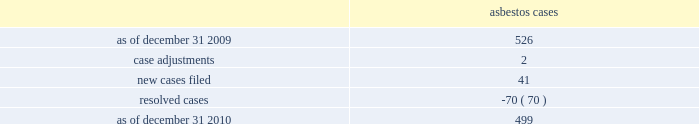Asbestos claims the company and several of its us subsidiaries are defendants in asbestos cases .
During the year ended december 31 , 2010 , asbestos case activity is as follows: .
Because many of these cases involve numerous plaintiffs , the company is subject to claims significantly in excess of the number of actual cases .
The company has reserves for defense costs related to claims arising from these matters .
Award proceedings in relation to domination agreement and squeeze-out on october 1 , 2004 , celanese gmbh and the company 2019s subsidiary , bcp holdings gmbh ( 201cbcp holdings 201d ) , a german limited liability company , entered into a domination agreement pursuant to which the bcp holdings became obligated to offer to acquire all outstanding celanese gmbh shares from the minority shareholders of celanese gmbh in return for payment of fair cash compensation ( the 201cpurchaser offer 201d ) .
The amount of this fair cash compensation was determined to be a41.92 per share in accordance with applicable german law .
All minority shareholders who elected not to sell their shares to the bcp holdings under the purchaser offer were entitled to remain shareholders of celanese gmbh and to receive from the bcp holdings a gross guaranteed annual payment of a3.27 per celanese gmbh share less certain corporate taxes in lieu of any dividend .
As of march 30 , 2005 , several minority shareholders of celanese gmbh had initiated special award proceedings seeking the court 2019s review of the amounts of the fair cash compensation and of the guaranteed annual payment offered in the purchaser offer under the domination agreement .
In the purchaser offer , 145387 shares were tendered at the fair cash compensation of a41.92 , and 924078 shares initially remained outstanding and were entitled to the guaranteed annual payment under the domination agreement .
As a result of these proceedings , the amount of the fair cash consideration and the guaranteed annual payment paid under the domination agreement could be increased by the court so that all minority shareholders , including those who have already tendered their shares in the purchaser offer for the fair cash compensation , could claim the respective higher amounts .
On december 12 , 2006 , the court of first instance appointed an expert to assist the court in determining the value of celanese gmbh .
On may 30 , 2006 the majority shareholder of celanese gmbh adopted a squeeze-out resolution under which all outstanding shares held by minority shareholders should be transferred to bcp holdings for a fair cash compensation of a66.99 per share ( the 201csqueeze-out 201d ) .
This shareholder resolution was challenged by shareholders but the squeeze-out became effective after the disputes were settled on december 22 , 2006 .
Award proceedings were subsequently filed by 79 shareholders against bcp holdings with the frankfurt district court requesting the court to set a higher amount for the squeeze-out compensation .
Pursuant to a settlement agreement between bcp holdings and certain former celanese gmbh shareholders , if the court sets a higher value for the fair cash compensation or the guaranteed payment under the purchaser offer or the squeeze-out compensation , former celanese gmbh shareholders who ceased to be shareholders of celanese gmbh due to the squeeze-out will be entitled to claim for their shares the higher of the compensation amounts determined by the court in these different proceedings related to the purchaser offer and the squeeze-out .
If the fair cash compensation determined by the court is higher than the squeeze-out compensation of a 66.99 , then 1069465 shares will be entitled to an adjustment .
If the court confirms the value of the fair cash compensation under the domination agreement but determines a higher value for the squeeze-out compensation , 924078 shares %%transmsg*** transmitting job : d77691 pcn : 148000000 ***%%pcmsg|148 |00010|yes|no|02/08/2011 16:10|0|0|page is valid , no graphics -- color : n| .
What is the net increase in the number of asbestos cases during 2010? 
Computations: (499 - 526)
Answer: -27.0. 